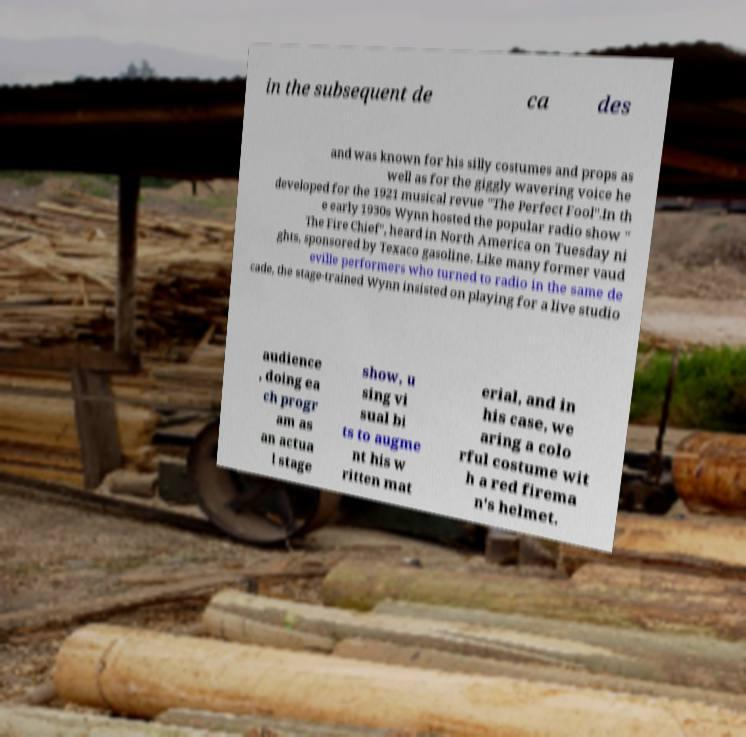What messages or text are displayed in this image? I need them in a readable, typed format. in the subsequent de ca des and was known for his silly costumes and props as well as for the giggly wavering voice he developed for the 1921 musical revue "The Perfect Fool".In th e early 1930s Wynn hosted the popular radio show " The Fire Chief", heard in North America on Tuesday ni ghts, sponsored by Texaco gasoline. Like many former vaud eville performers who turned to radio in the same de cade, the stage-trained Wynn insisted on playing for a live studio audience , doing ea ch progr am as an actua l stage show, u sing vi sual bi ts to augme nt his w ritten mat erial, and in his case, we aring a colo rful costume wit h a red firema n's helmet. 